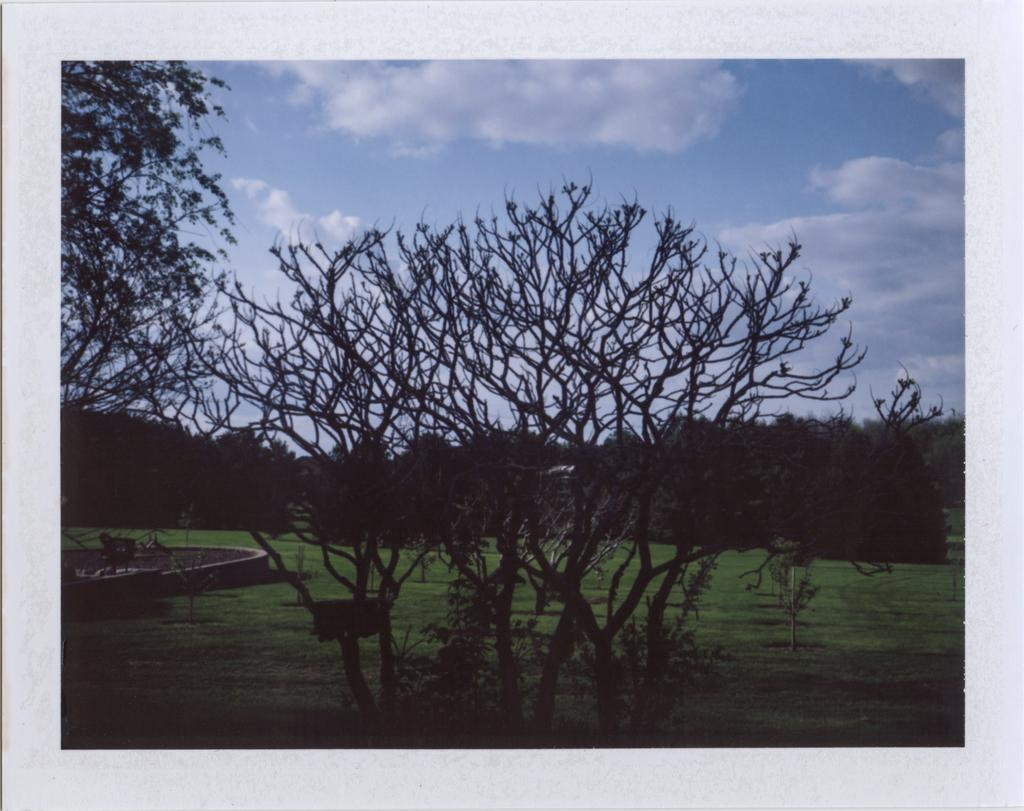What type of vegetation can be seen in the image? There are trees and grass in the image. What else is visible in the image besides the vegetation? There is an unspecified item in the image. What can be seen in the background of the image? The sky is visible behind the trees in the image. What type of pear is hanging from the tree in the image? There is no pear present in the image; it only features trees and grass. How many parcels can be seen on the sidewalk in the image? There is no sidewalk or parcel present in the image. 